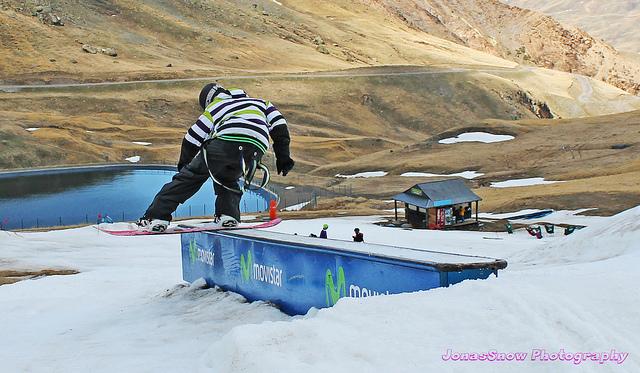What is this person standing on?
Quick response, please. Snowboard. Is the entire area covered with snow?
Keep it brief. No. Is there snow on the holy ground?
Answer briefly. No. 